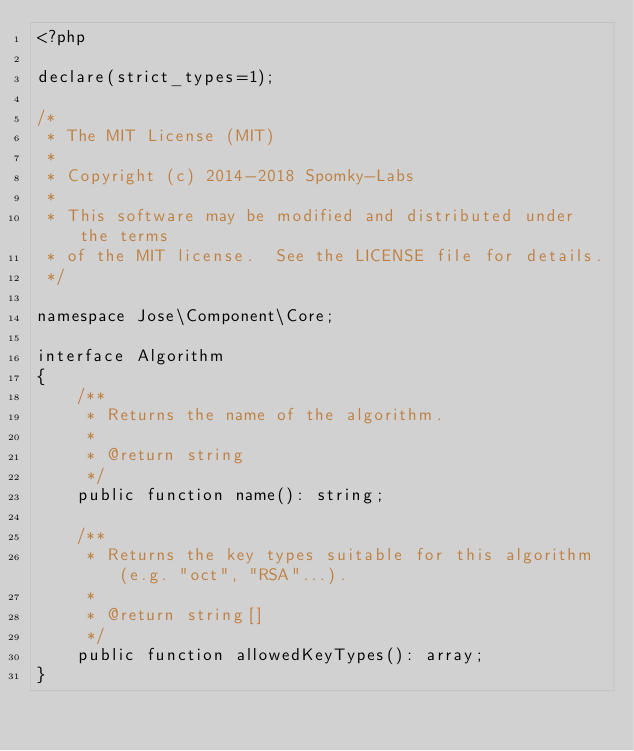<code> <loc_0><loc_0><loc_500><loc_500><_PHP_><?php

declare(strict_types=1);

/*
 * The MIT License (MIT)
 *
 * Copyright (c) 2014-2018 Spomky-Labs
 *
 * This software may be modified and distributed under the terms
 * of the MIT license.  See the LICENSE file for details.
 */

namespace Jose\Component\Core;

interface Algorithm
{
    /**
     * Returns the name of the algorithm.
     *
     * @return string
     */
    public function name(): string;

    /**
     * Returns the key types suitable for this algorithm (e.g. "oct", "RSA"...).
     *
     * @return string[]
     */
    public function allowedKeyTypes(): array;
}
</code> 